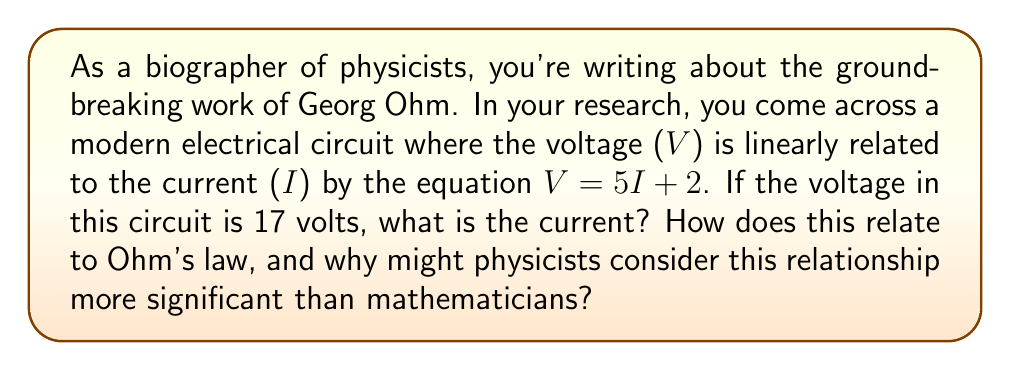Can you solve this math problem? To solve this problem, we need to use the given linear equation and solve for the current (I) when the voltage (V) is 17 volts.

1) The given equation is:
   $V = 5I + 2$

2) We know that V = 17, so we can substitute this:
   $17 = 5I + 2$

3) Subtract 2 from both sides:
   $15 = 5I$

4) Divide both sides by 5:
   $3 = I$

This result shows that when the voltage is 17 volts, the current is 3 amperes.

Relating this to Ohm's law:
Ohm's law states that $V = IR$, where R is the resistance. In our equation $V = 5I + 2$, the coefficient 5 represents the resistance, and the +2 represents an additional constant voltage source in the circuit.

Physicists might consider this relationship more significant than mathematicians because:

1) It describes a real-world phenomenon in electrical circuits.
2) It's an extension of Ohm's law, which is a fundamental principle in physics.
3) It demonstrates how physical laws can be represented mathematically, bridging the gap between theoretical physics and practical applications.

Mathematicians might view this simply as a linear equation, while physicists see it as a representation of physical laws governing electrical circuits.
Answer: The current in the circuit when the voltage is 17 volts is 3 amperes. 